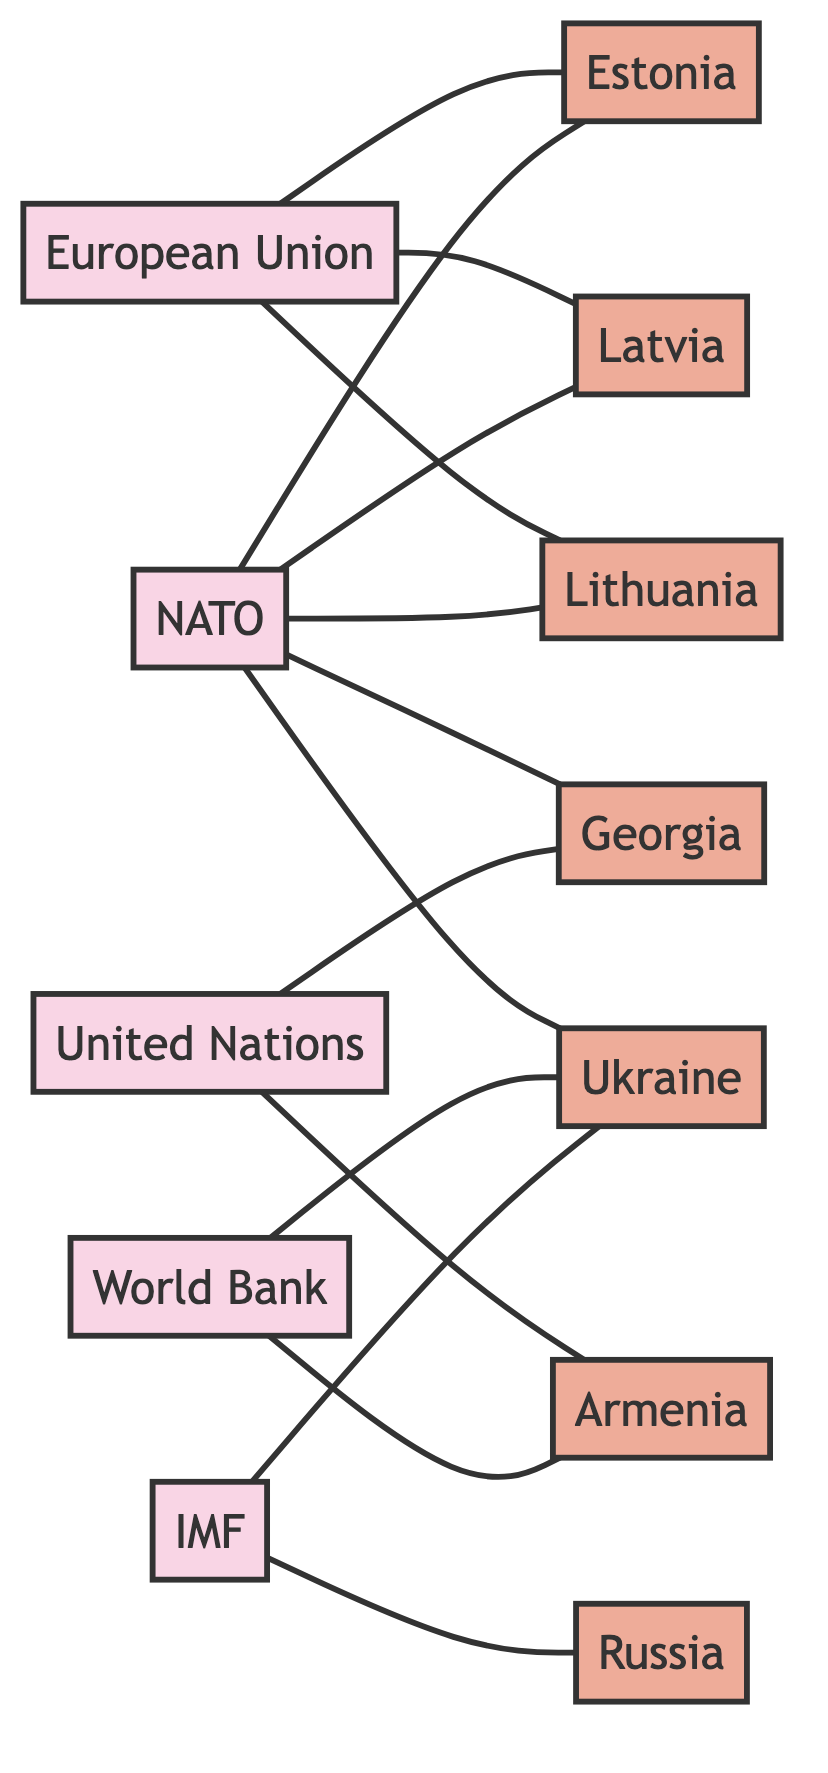What organizations are linked to Estonia? By looking at the diagram, Estonia is connected to the European Union through a membership relationship, and to NATO through a security support relationship.
Answer: European Union, NATO How many post-Soviet countries are represented in the diagram? The diagram includes seven post-Soviet countries: Estonia, Latvia, Lithuania, Georgia, Ukraine, Russia, and Armenia.
Answer: 7 Which organization provides financial support to Ukraine? From the diagram, the World Bank and the International Monetary Fund (IMF) have relationships indicating financial support or assistance provided to Ukraine.
Answer: World Bank, IMF What type of relationship does NATO have with Georgia? The connection shown in the diagram indicates that NATO has a security cooperation relationship with Georgia.
Answer: security cooperation Which international organization offers development projects to Armenia? The diagram specifies that the United Nations is involved with Armenia through development projects.
Answer: United Nations How many edges are connected to the World Bank? The diagram shows that the World Bank has two edges connecting it to Ukraine and Armenia, representing financial support.
Answer: 2 What kind of support does NATO provide to Latvia? The diagram indicates that NATO provides security support to Latvia as one of its member states.
Answer: security support Which post-Soviet country is linked to the International Monetary Fund? According to the diagram, Russia and Ukraine are connected to the IMF, the relationship being financial negotiations with Russia and financial assistance with Ukraine.
Answer: Russia, Ukraine Which international organization is connected to both Ukraine and Armenia? The diagram demonstrates that the World Bank is connected to both Ukraine and Armenia through financial support.
Answer: World Bank 